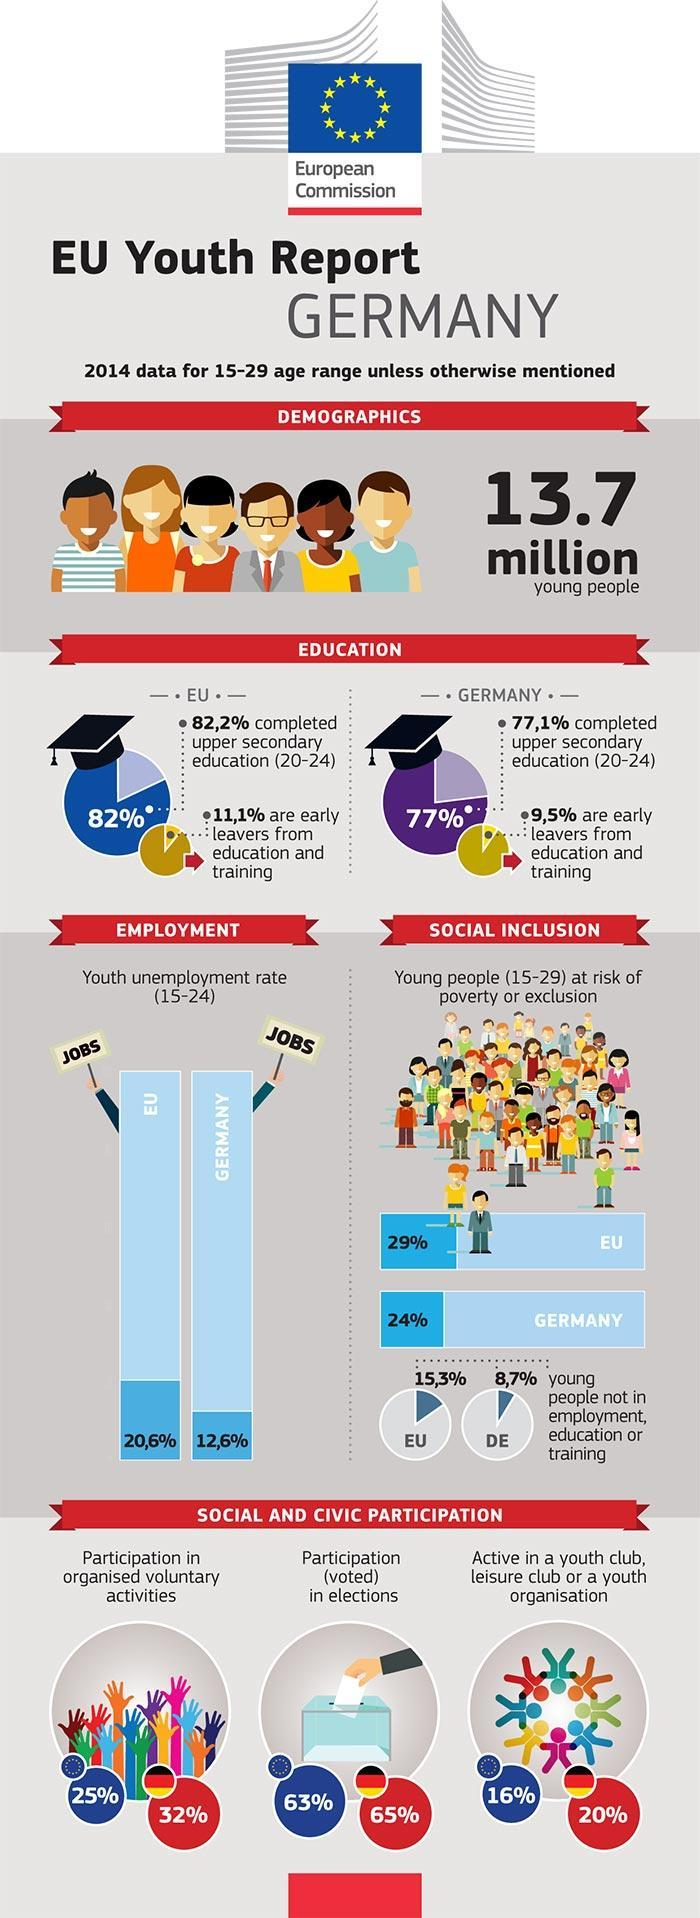What percentage of youth in EU participate in elections ?
Answer the question with a short phrase. 63% What is percentage of youth participating in organized voluntary activities in EU? 25% What is percentage of youth in EU are active in a youth organization? 16% What is percentage of youth in Germany are active in a youth organization? 20% What is percentage of youth participating in organized voluntary activities in Germany? 32% What percentage of youth in Germany participate in elections ? 65% 